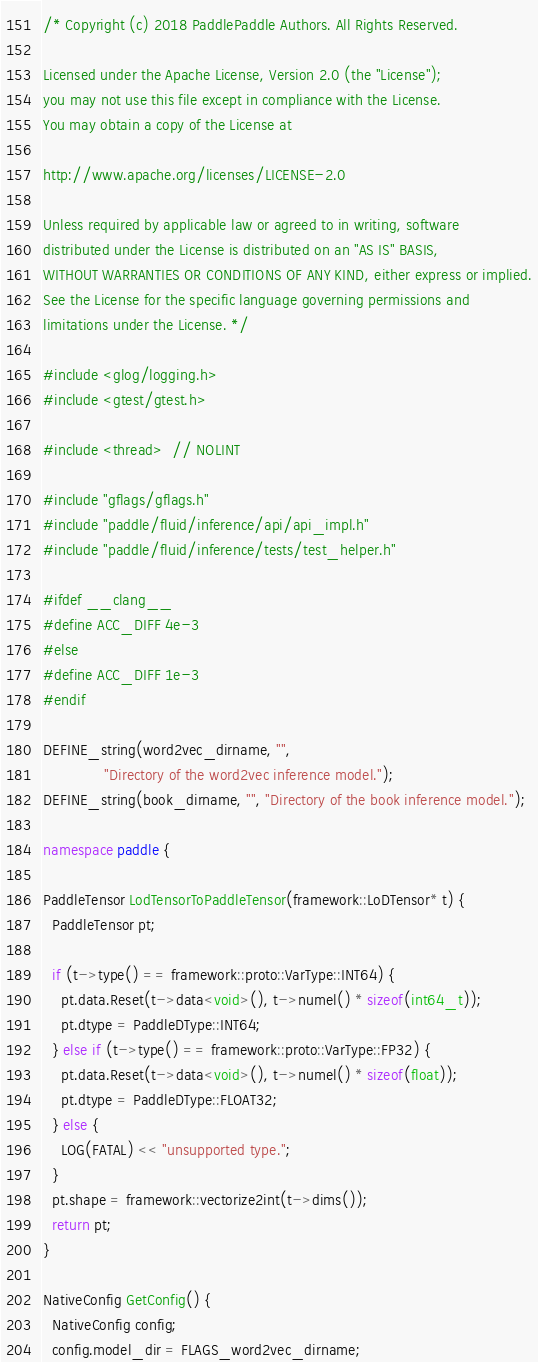Convert code to text. <code><loc_0><loc_0><loc_500><loc_500><_C++_>/* Copyright (c) 2018 PaddlePaddle Authors. All Rights Reserved.

Licensed under the Apache License, Version 2.0 (the "License");
you may not use this file except in compliance with the License.
You may obtain a copy of the License at

http://www.apache.org/licenses/LICENSE-2.0

Unless required by applicable law or agreed to in writing, software
distributed under the License is distributed on an "AS IS" BASIS,
WITHOUT WARRANTIES OR CONDITIONS OF ANY KIND, either express or implied.
See the License for the specific language governing permissions and
limitations under the License. */

#include <glog/logging.h>
#include <gtest/gtest.h>

#include <thread>  // NOLINT

#include "gflags/gflags.h"
#include "paddle/fluid/inference/api/api_impl.h"
#include "paddle/fluid/inference/tests/test_helper.h"

#ifdef __clang__
#define ACC_DIFF 4e-3
#else
#define ACC_DIFF 1e-3
#endif

DEFINE_string(word2vec_dirname, "",
              "Directory of the word2vec inference model.");
DEFINE_string(book_dirname, "", "Directory of the book inference model.");

namespace paddle {

PaddleTensor LodTensorToPaddleTensor(framework::LoDTensor* t) {
  PaddleTensor pt;

  if (t->type() == framework::proto::VarType::INT64) {
    pt.data.Reset(t->data<void>(), t->numel() * sizeof(int64_t));
    pt.dtype = PaddleDType::INT64;
  } else if (t->type() == framework::proto::VarType::FP32) {
    pt.data.Reset(t->data<void>(), t->numel() * sizeof(float));
    pt.dtype = PaddleDType::FLOAT32;
  } else {
    LOG(FATAL) << "unsupported type.";
  }
  pt.shape = framework::vectorize2int(t->dims());
  return pt;
}

NativeConfig GetConfig() {
  NativeConfig config;
  config.model_dir = FLAGS_word2vec_dirname;</code> 